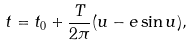Convert formula to latex. <formula><loc_0><loc_0><loc_500><loc_500>t = t _ { 0 } + \frac { T } { 2 \pi } ( u - e \sin { u } ) ,</formula> 